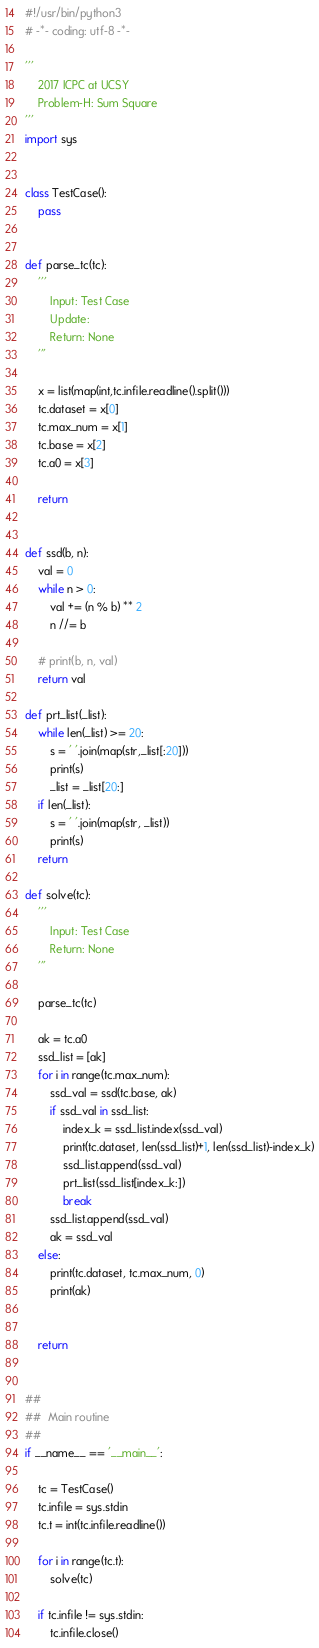Convert code to text. <code><loc_0><loc_0><loc_500><loc_500><_Python_>#!/usr/bin/python3
# -*- coding: utf-8 -*-

'''
    2017 ICPC at UCSY
    Problem-H: Sum Square
'''
import sys


class TestCase():
    pass


def parse_tc(tc):
    '''
        Input: Test Case
        Update: 
        Return: None
    '''

    x = list(map(int,tc.infile.readline().split()))
    tc.dataset = x[0]
    tc.max_num = x[1]
    tc.base = x[2]
    tc.a0 = x[3]

    return


def ssd(b, n):
    val = 0
    while n > 0:
        val += (n % b) ** 2
        n //= b

    # print(b, n, val)
    return val

def prt_list(_list):
    while len(_list) >= 20:
        s = ' '.join(map(str,_list[:20]))
        print(s)
        _list = _list[20:]
    if len(_list):
        s = ' '.join(map(str, _list))
        print(s)
    return

def solve(tc):
    '''
        Input: Test Case
        Return: None
    '''

    parse_tc(tc)

    ak = tc.a0
    ssd_list = [ak]
    for i in range(tc.max_num):
        ssd_val = ssd(tc.base, ak)
        if ssd_val in ssd_list:
            index_k = ssd_list.index(ssd_val)
            print(tc.dataset, len(ssd_list)+1, len(ssd_list)-index_k)
            ssd_list.append(ssd_val)
            prt_list(ssd_list[index_k:])
            break
        ssd_list.append(ssd_val)
        ak = ssd_val
    else:
        print(tc.dataset, tc.max_num, 0)
        print(ak)


    return


##
##  Main routine
##
if __name__ == '__main__':
    
    tc = TestCase()
    tc.infile = sys.stdin
    tc.t = int(tc.infile.readline())
    
    for i in range(tc.t):
        solve(tc)

    if tc.infile != sys.stdin:
        tc.infile.close()
</code> 